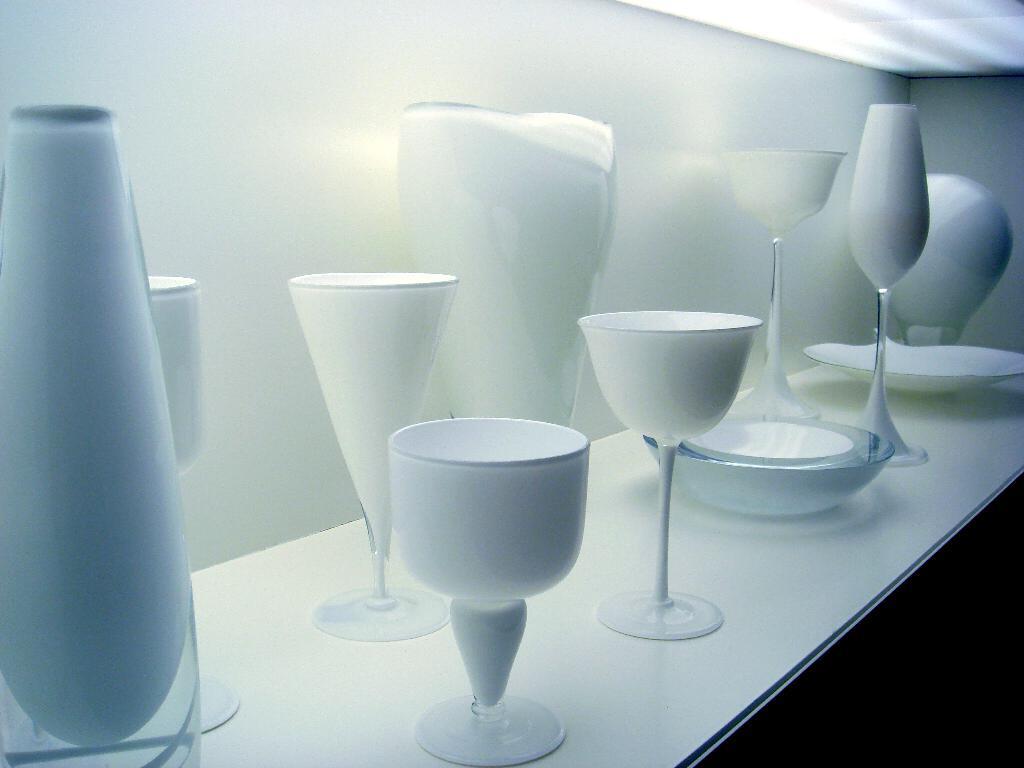Please provide a concise description of this image. In this image I can see number of glasses, plates and few bowls. 